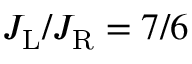<formula> <loc_0><loc_0><loc_500><loc_500>J _ { L } / J _ { R } = 7 / 6</formula> 